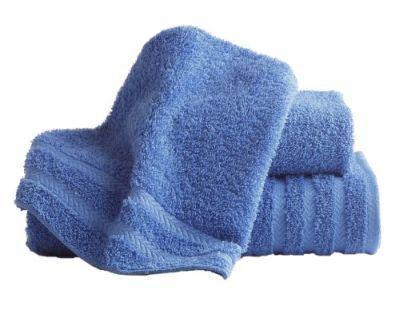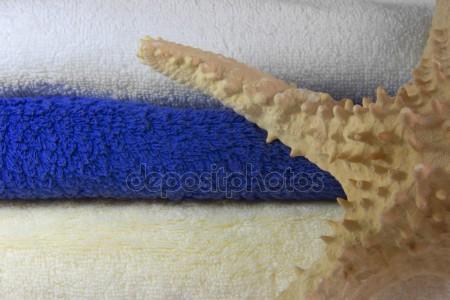The first image is the image on the left, the second image is the image on the right. Assess this claim about the two images: "There are four towels on the left and three towels on the right, all folded neatly". Correct or not? Answer yes or no. No. The first image is the image on the left, the second image is the image on the right. Examine the images to the left and right. Is the description "A stack of three or more towels has folded washcloths on top." accurate? Answer yes or no. No. 